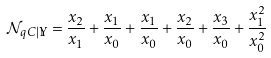Convert formula to latex. <formula><loc_0><loc_0><loc_500><loc_500>\mathcal { N } _ { q C | \mathbb { Y } } = \frac { x _ { 2 } } { x _ { 1 } } + \frac { x _ { 1 } } { x _ { 0 } } + \frac { x _ { 1 } } { x _ { 0 } } + \frac { x _ { 2 } } { x _ { 0 } } + \frac { x _ { 3 } } { x _ { 0 } } + \frac { x _ { 1 } ^ { 2 } } { x _ { 0 } ^ { 2 } }</formula> 